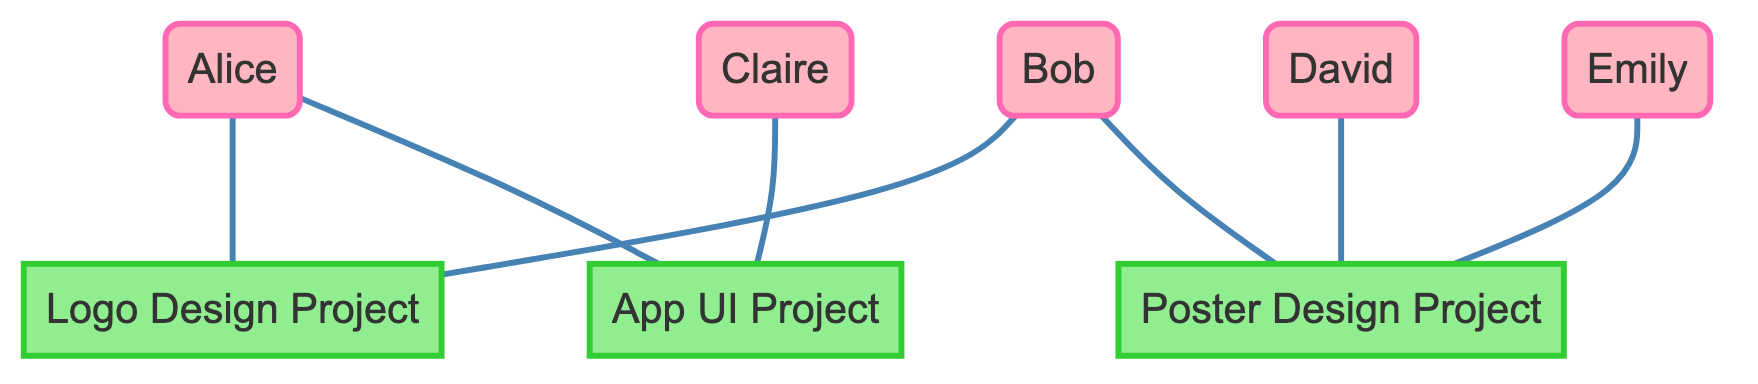What is the total number of nodes in the graph? The graph has eight nodes: five people (Alice, Bob, Claire, David, Emily) and three projects (Logo Design Project, App UI Project, Poster Design Project). Counting them gives a total of eight.
Answer: 8 Which project is Alice associated with? Alice is connected to two projects: Logo Design Project and App UI Project. However, since the question asks for one, we can mention either.
Answer: Logo Design Project Who worked on the Poster Design Project? The Poster Design Project is linked to three nodes: David, Emily, and Bob. Hence, the answer can list any of these individuals as involved.
Answer: David, Emily, Bob How many projects are Claire and Emily associated with? Claire is linked to one project (App UI Project), and Emily is linked to one project (Poster Design Project). Therefore, Claire and Emily are associated with one project each. The total would be two.
Answer: 2 Which project has the most people collaborating on it? The Logo Design Project has two collaborators (Alice and Bob), the App UI Project has two (Alice and Claire), and the Poster Design Project has three (David, Emily, and Bob). Thus, the Poster Design Project has the most collaborators.
Answer: Poster Design Project Is there any project that has no connections? By reviewing the projects in the diagram, all three projects have at least one connection with people. Thus, there are no projects without connections.
Answer: No Which person is associated with the most projects? Both Alice and Bob are each connected to two projects. No other individuals are linked to more than one project. Hence, both Alice and Bob have the highest association.
Answer: Alice, Bob What is the relationship between Claire and the Logo Design Project? Claire has no direct connection to the Logo Design Project in the graph. She is only connected to the App UI Project. Thus, there is no relationship between Claire and the Logo Design Project.
Answer: No relationship How many edges are in the graph? The graph consists of seven edges which represent the collaborations between individuals and their associated projects. Each edge connects a person to a project or another person to a project.
Answer: 7 